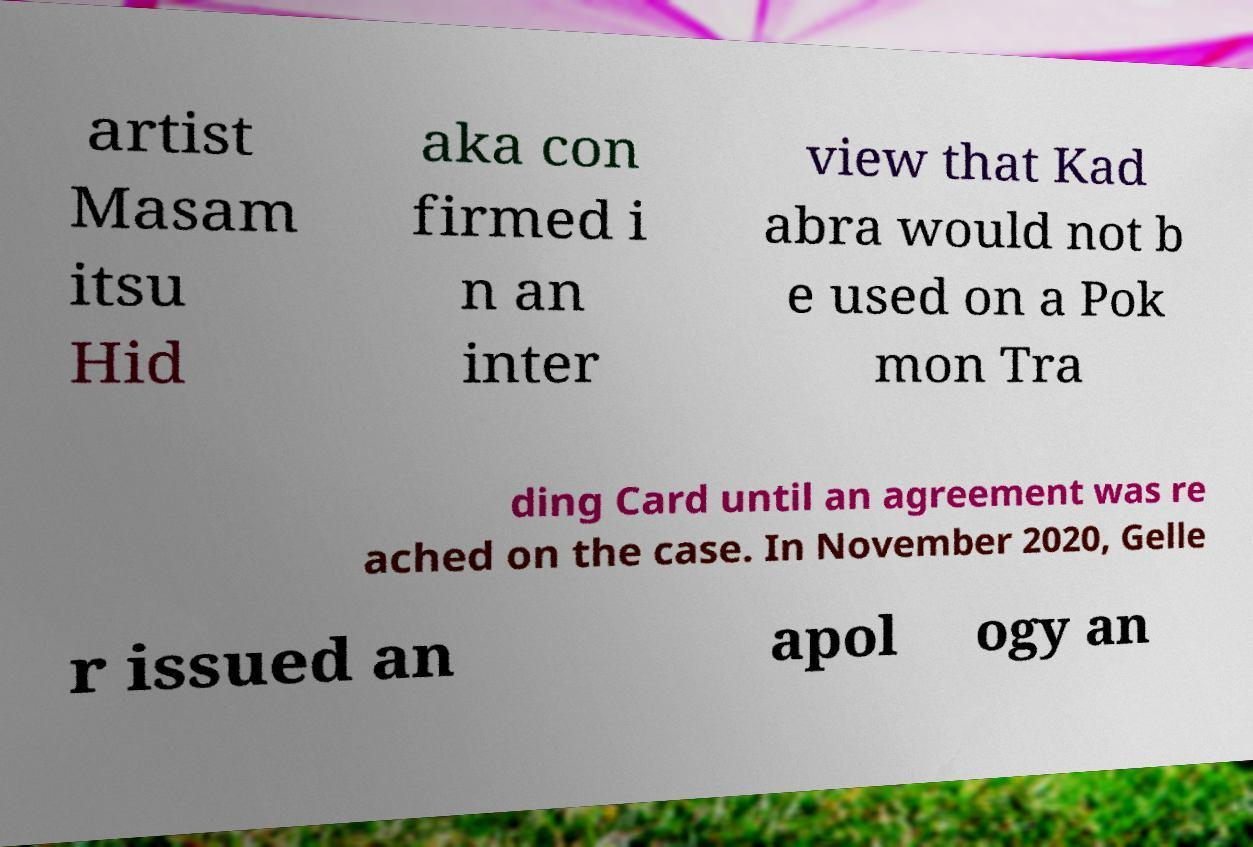Please identify and transcribe the text found in this image. artist Masam itsu Hid aka con firmed i n an inter view that Kad abra would not b e used on a Pok mon Tra ding Card until an agreement was re ached on the case. In November 2020, Gelle r issued an apol ogy an 